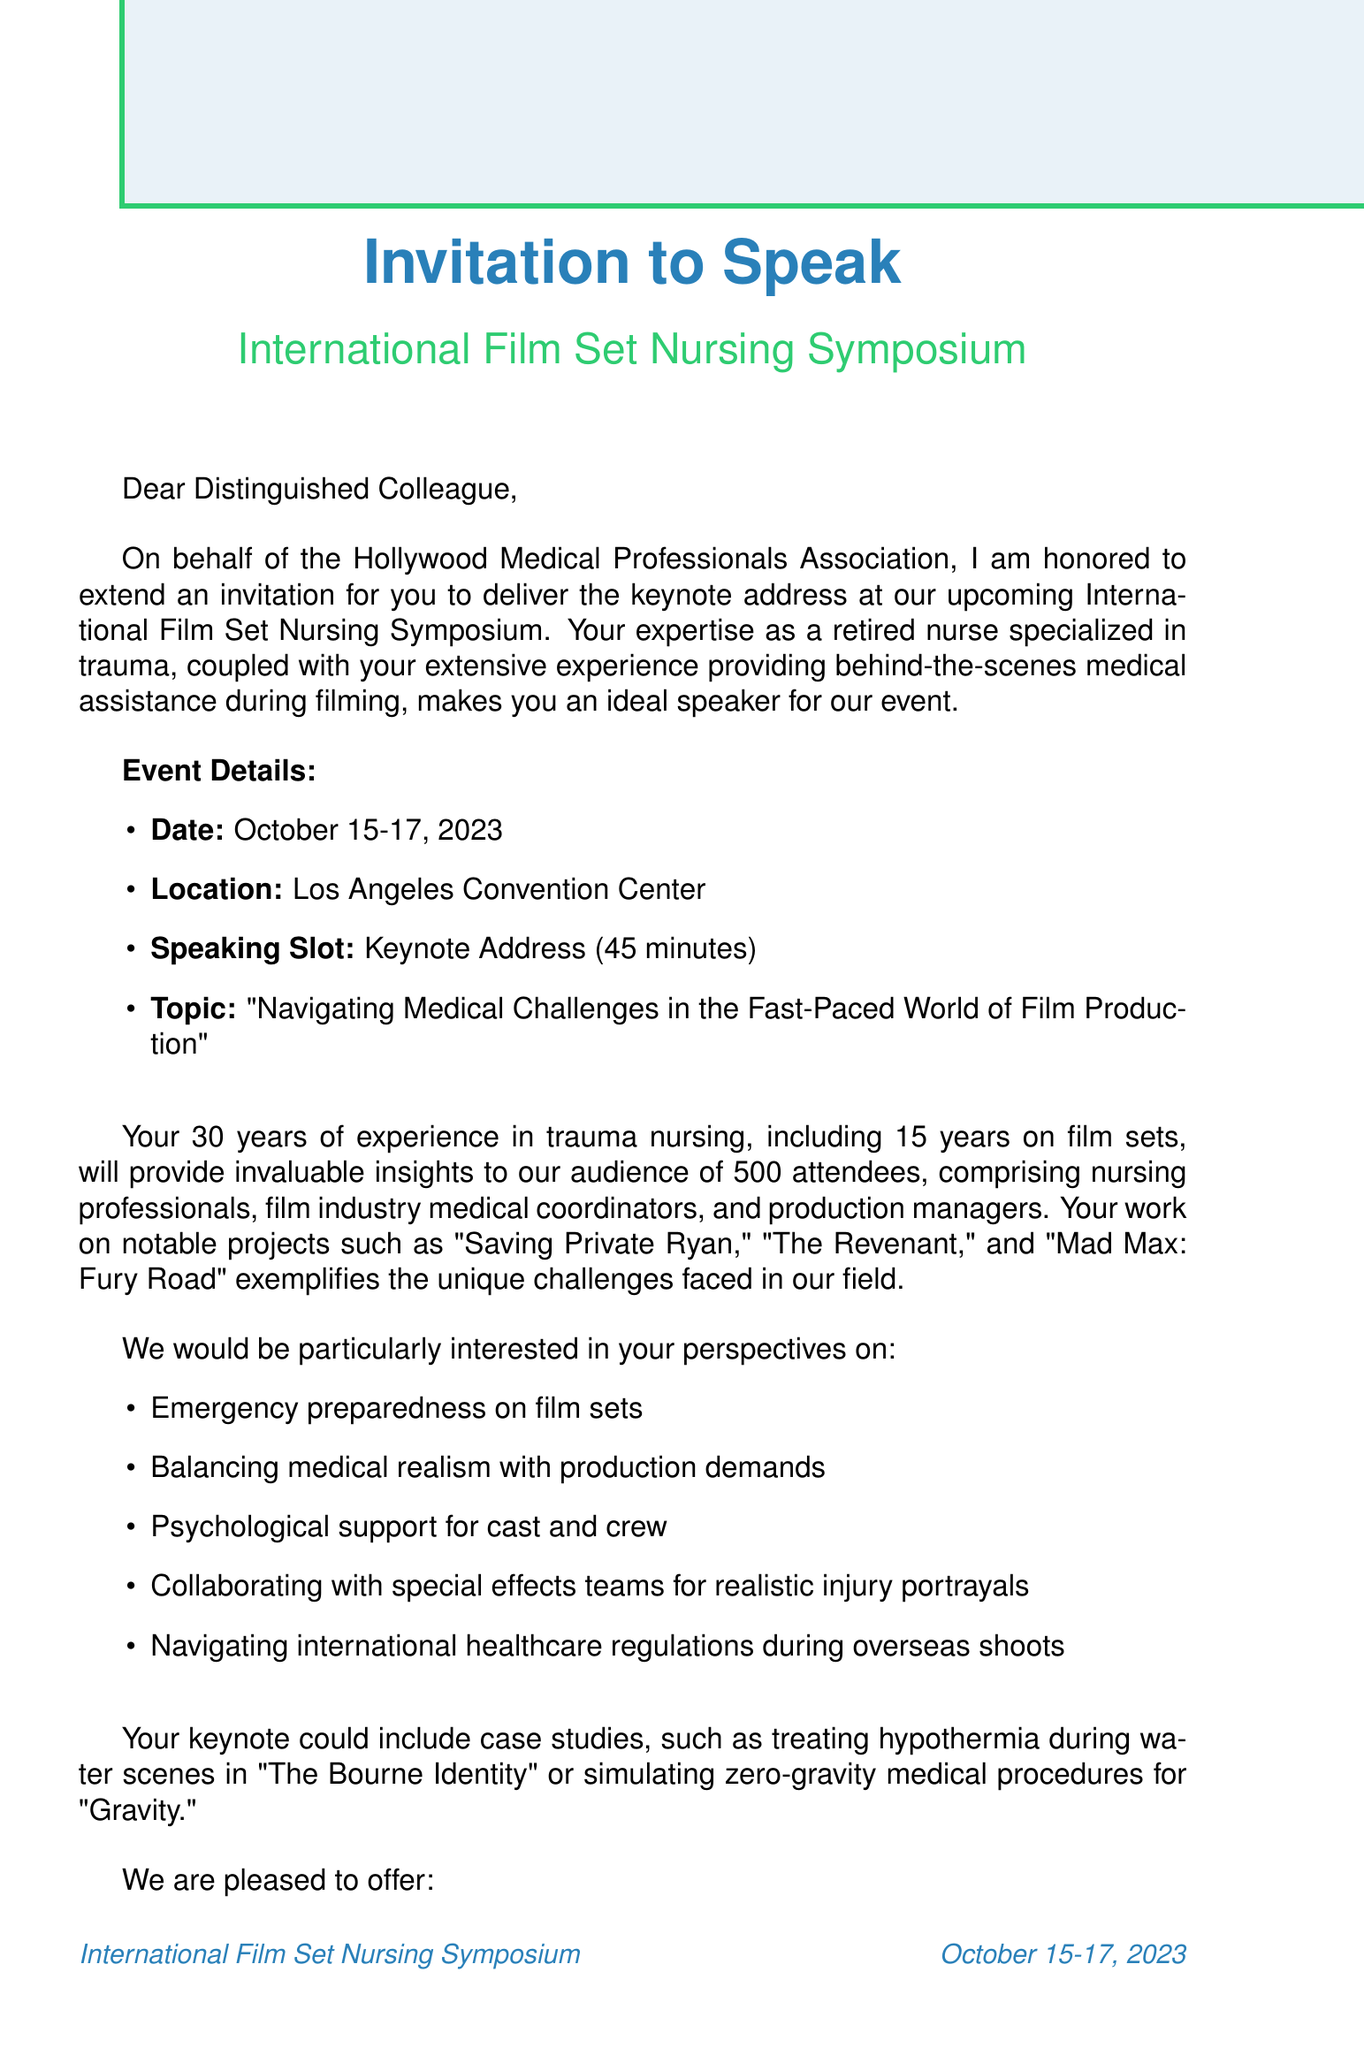What is the name of the conference? The name of the conference is mentioned in the document.
Answer: International Film Set Nursing Symposium What are the dates of the symposium? The specific dates for the event are listed in the document.
Answer: October 15-17, 2023 Where is the event being held? The location of the conference is specified in the document.
Answer: Los Angeles Convention Center What is the duration of the speaking slot? The document specifies how long the keynote address will be.
Answer: 45 minutes What is a key topic to address? One of the key topics to be covered is indicated in the document.
Answer: Emergency preparedness on film sets How many expected attendees are there? The document states the projected number of attendees for the event.
Answer: 500 What is the per diem amount for meals? The amount allocated for meals and incidentals is provided in the document.
Answer: $150 What notable project is mentioned in regards to on-set challenges? The document mentions notable projects where unique challenges were faced.
Answer: Saving Private Ryan What organization is organizing the event? The name of the organizing body is included in the document.
Answer: Hollywood Medical Professionals Association 